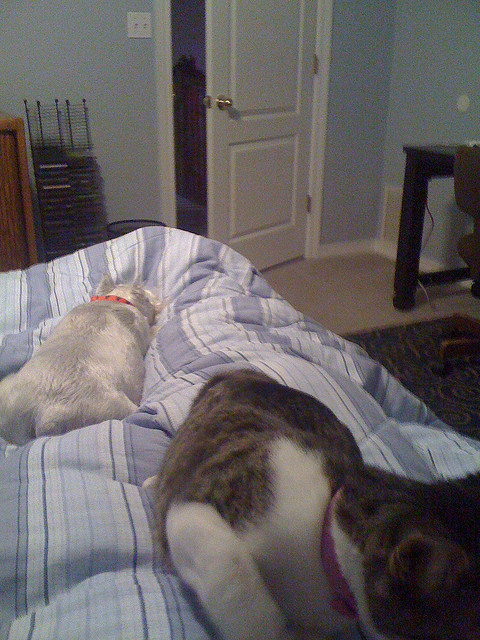<image>What size of bed is this? I am not sure what size the bed is. It could either be a queen, full or twin size. What size of bed is this? It is ambiguous what the size of the bed is. It can be seen as queen, full or twin bed. 